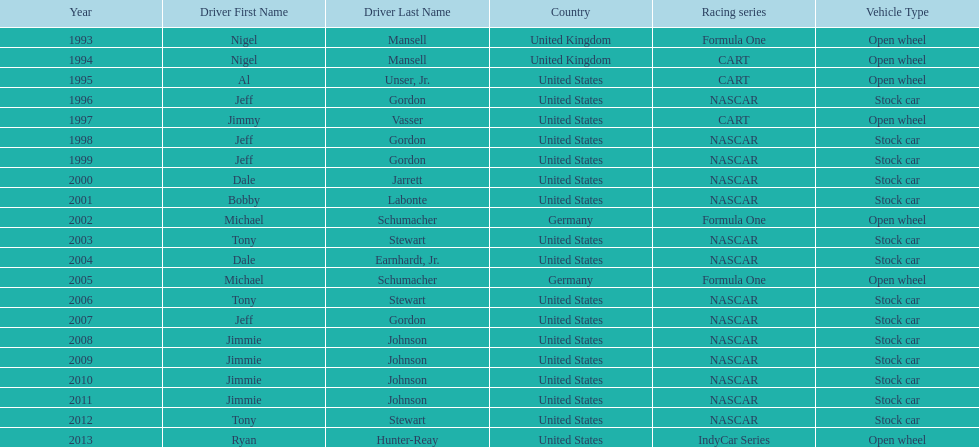Which drivers have won the best driver espy award? Nigel Mansell, Nigel Mansell, Al Unser, Jr., Jeff Gordon, Jimmy Vasser, Jeff Gordon, Jeff Gordon, Dale Jarrett, Bobby Labonte, Michael Schumacher, Tony Stewart, Dale Earnhardt, Jr., Michael Schumacher, Tony Stewart, Jeff Gordon, Jimmie Johnson, Jimmie Johnson, Jimmie Johnson, Jimmie Johnson, Tony Stewart, Ryan Hunter-Reay. Of these, which only appear once? Al Unser, Jr., Jimmy Vasser, Dale Jarrett, Dale Earnhardt, Jr., Ryan Hunter-Reay. Which of these are from the cart racing series? Al Unser, Jr., Jimmy Vasser. Of these, which received their award first? Al Unser, Jr. 